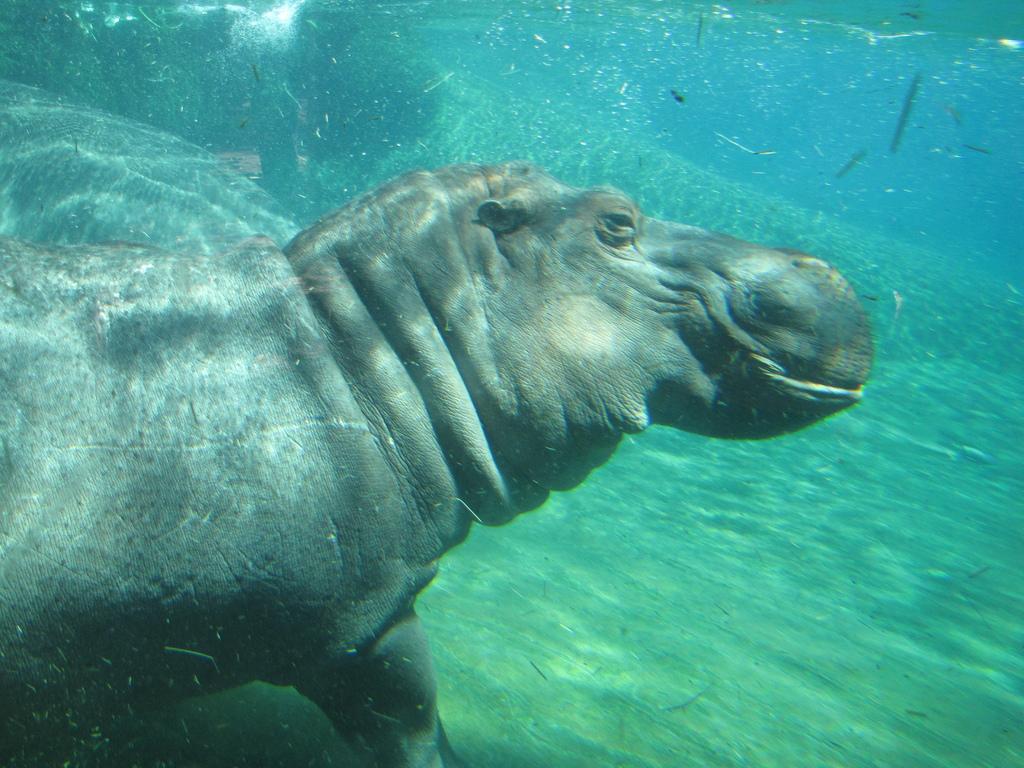Could you give a brief overview of what you see in this image? In this image I can see an underwater picture in which I can see an aquatic animal in the water. 